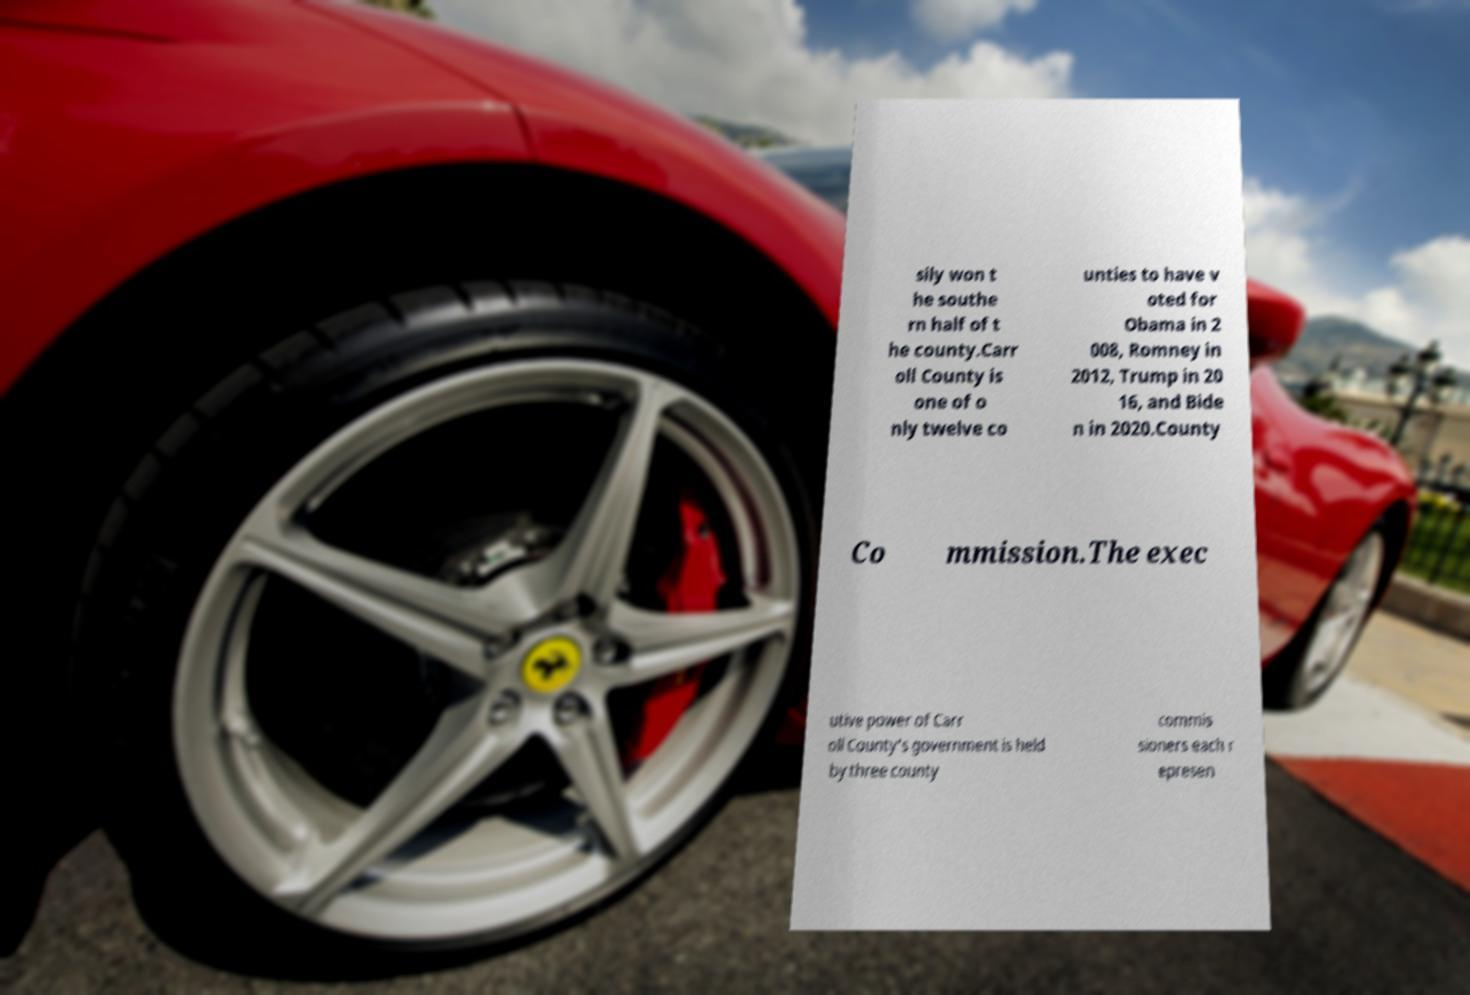Can you accurately transcribe the text from the provided image for me? sily won t he southe rn half of t he county.Carr oll County is one of o nly twelve co unties to have v oted for Obama in 2 008, Romney in 2012, Trump in 20 16, and Bide n in 2020.County Co mmission.The exec utive power of Carr oll County's government is held by three county commis sioners each r epresen 